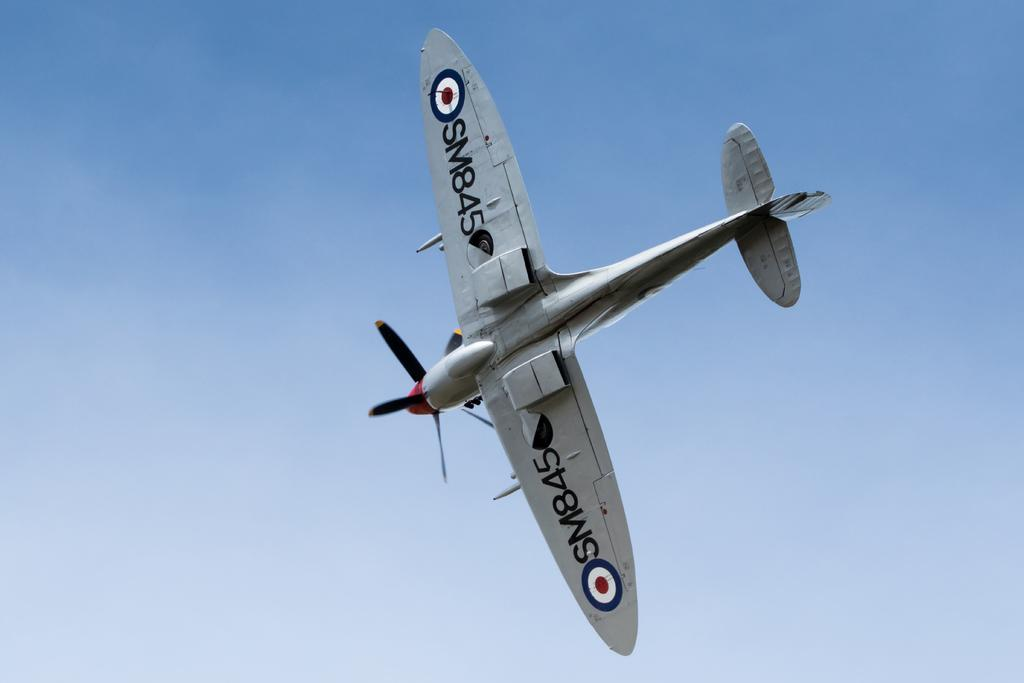<image>
Share a concise interpretation of the image provided. The British propeller plane SM845 flies in the blue sky. 